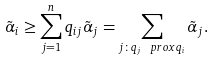Convert formula to latex. <formula><loc_0><loc_0><loc_500><loc_500>\tilde { \alpha } _ { i } \geq \sum _ { j = 1 } ^ { n } q _ { i j } \tilde { \alpha } _ { j } = \sum _ { j \colon q _ { j } \ p r o x q _ { i } } \tilde { \alpha } _ { j } .</formula> 